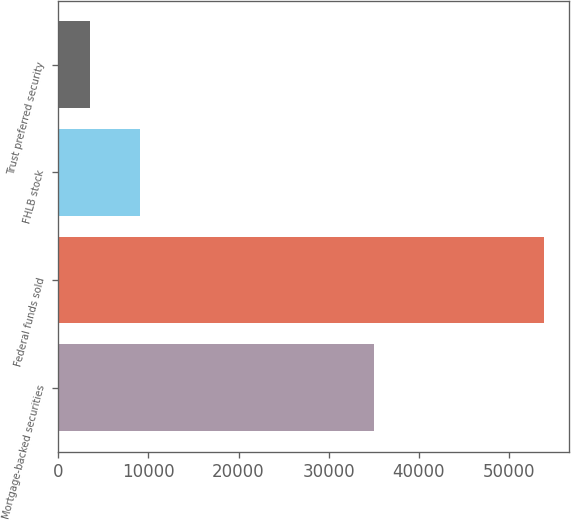Convert chart to OTSL. <chart><loc_0><loc_0><loc_500><loc_500><bar_chart><fcel>Mortgage-backed securities<fcel>Federal funds sold<fcel>FHLB stock<fcel>Trust preferred security<nl><fcel>35084<fcel>53946<fcel>9091<fcel>3500<nl></chart> 